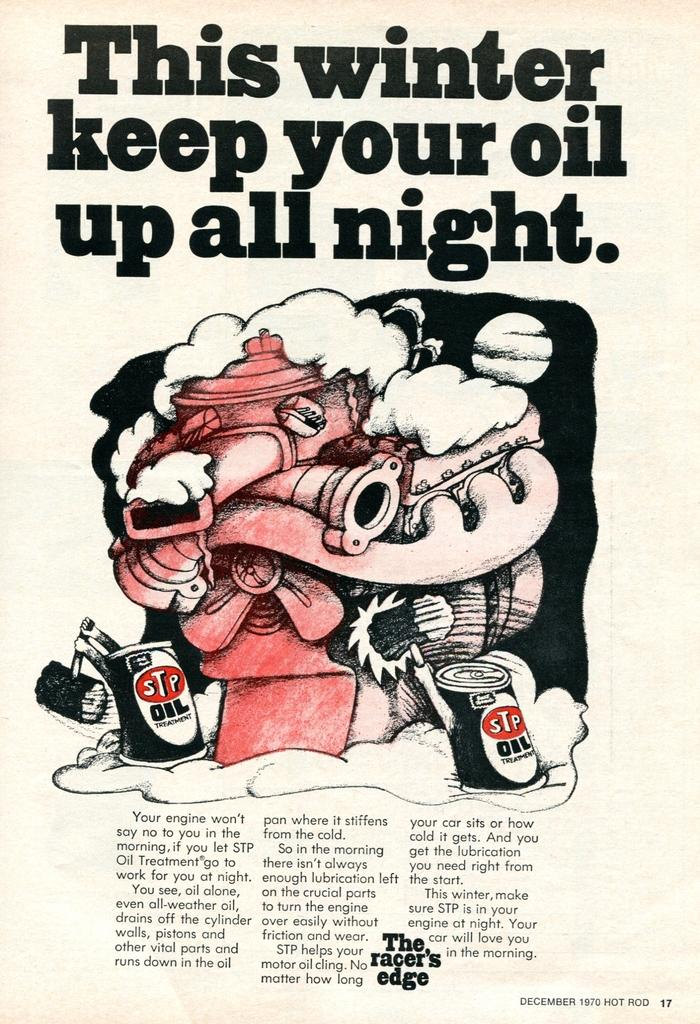What is the main object in the image? There is a magazine in the image. What type of image is on the magazine? The magazine has a cartoon image. What can be found under the cartoon image? There is information under the cartoon image. What type of bed is depicted in the cartoon image on the magazine? There is no bed depicted in the cartoon image on the magazine; the image is a cartoon, not a scene from a bedroom. 